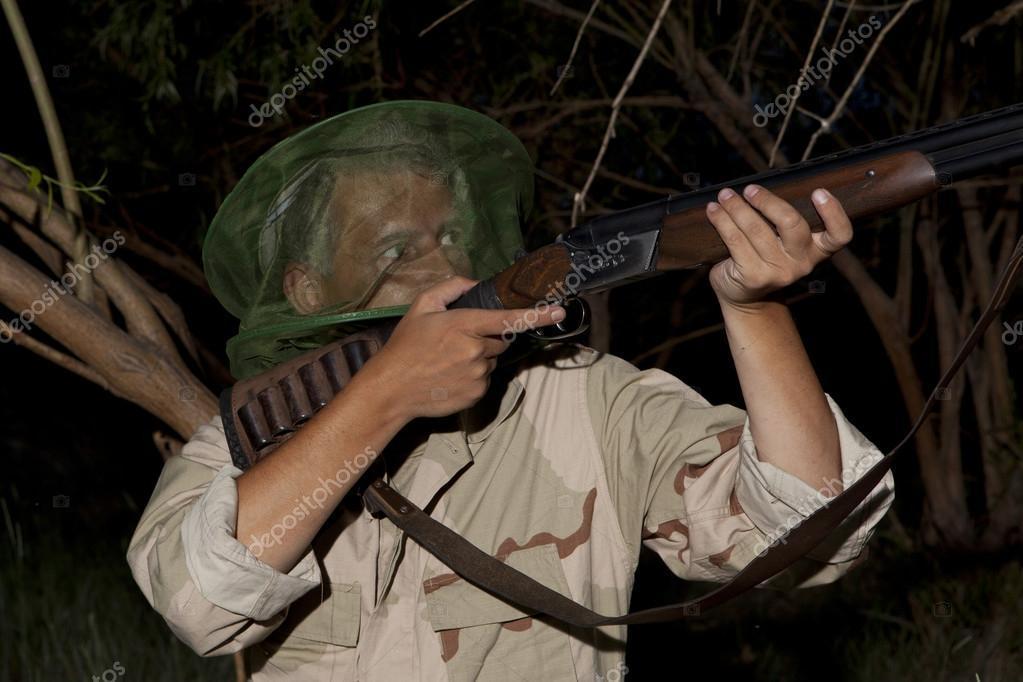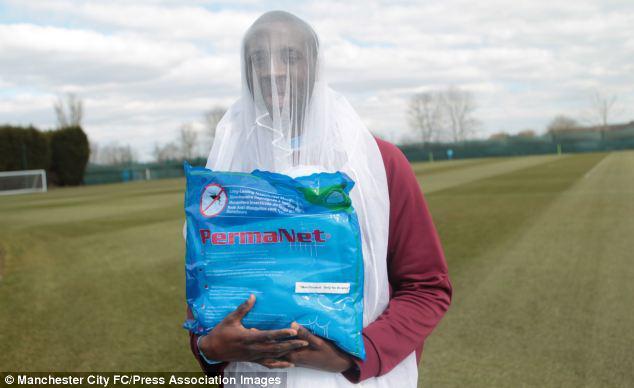The first image is the image on the left, the second image is the image on the right. Evaluate the accuracy of this statement regarding the images: "An image shows a dark-skinned human baby surrounded by netting.". Is it true? Answer yes or no. No. The first image is the image on the left, the second image is the image on the right. Evaluate the accuracy of this statement regarding the images: "A net is set up over a bed in one of the images.". Is it true? Answer yes or no. No. 